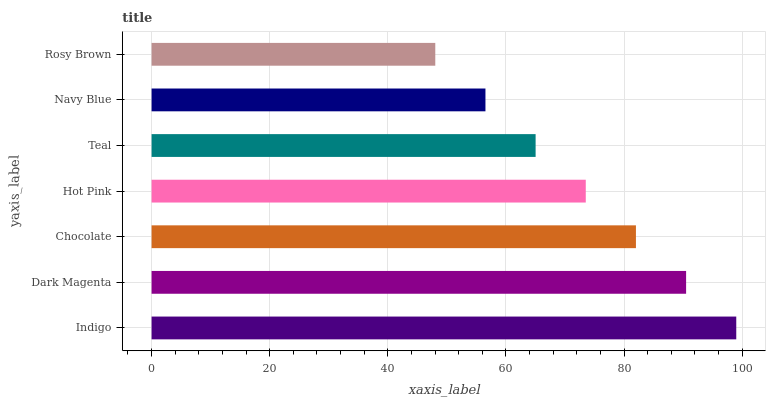Is Rosy Brown the minimum?
Answer yes or no. Yes. Is Indigo the maximum?
Answer yes or no. Yes. Is Dark Magenta the minimum?
Answer yes or no. No. Is Dark Magenta the maximum?
Answer yes or no. No. Is Indigo greater than Dark Magenta?
Answer yes or no. Yes. Is Dark Magenta less than Indigo?
Answer yes or no. Yes. Is Dark Magenta greater than Indigo?
Answer yes or no. No. Is Indigo less than Dark Magenta?
Answer yes or no. No. Is Hot Pink the high median?
Answer yes or no. Yes. Is Hot Pink the low median?
Answer yes or no. Yes. Is Indigo the high median?
Answer yes or no. No. Is Dark Magenta the low median?
Answer yes or no. No. 